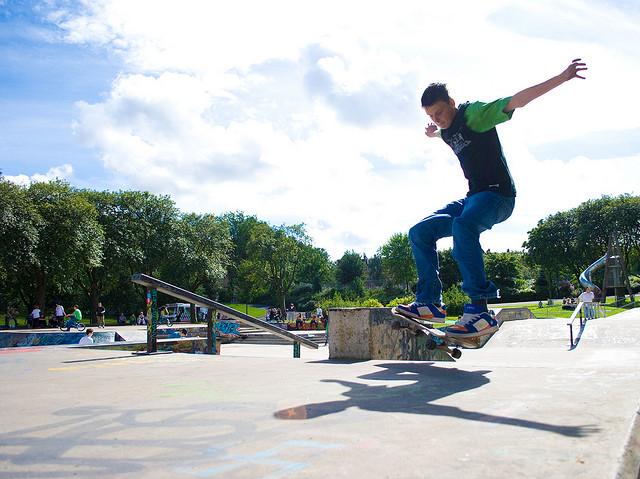What kind of park is this?
Answer briefly. Skate. What color are this guys sleeves?
Keep it brief. Green. Is this person in the air or on the ground?
Short answer required. Air. Is the boy fully clothed?
Keep it brief. Yes. 